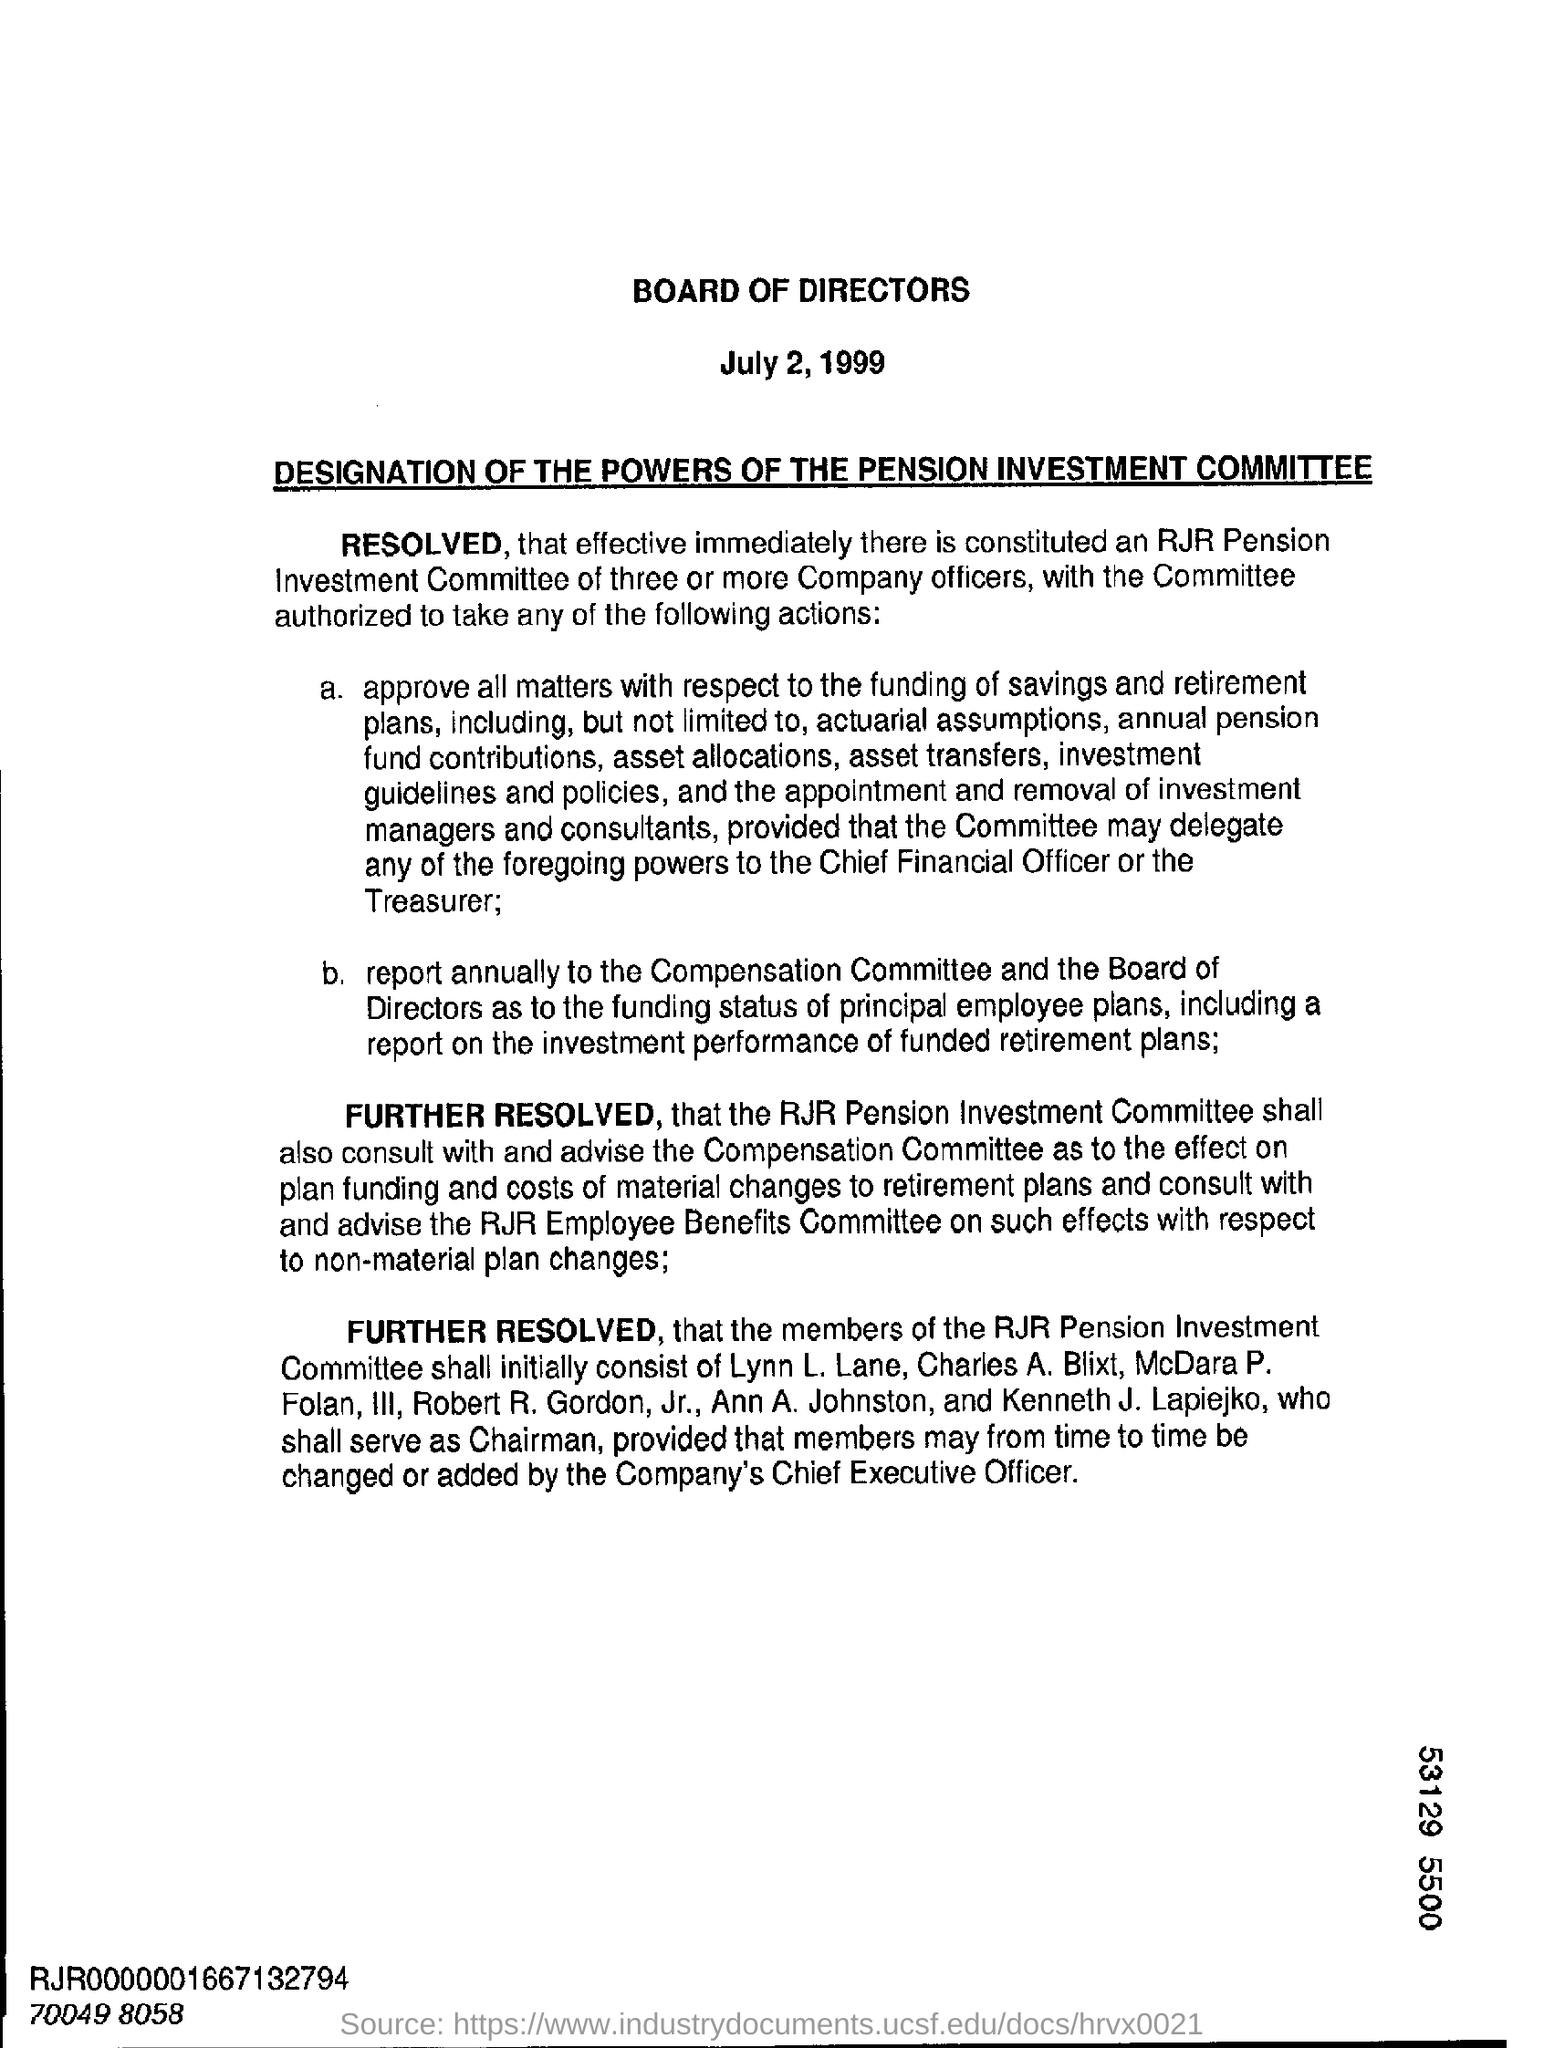List a handful of essential elements in this visual. The date on the document is July 2, 1999. At the meeting, it was announced that Kenneth J. Lapiejko would serve as the chairman. 